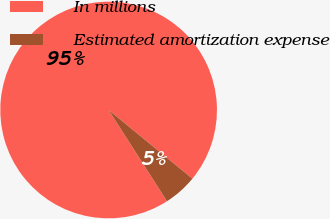Convert chart to OTSL. <chart><loc_0><loc_0><loc_500><loc_500><pie_chart><fcel>In millions<fcel>Estimated amortization expense<nl><fcel>94.99%<fcel>5.01%<nl></chart> 